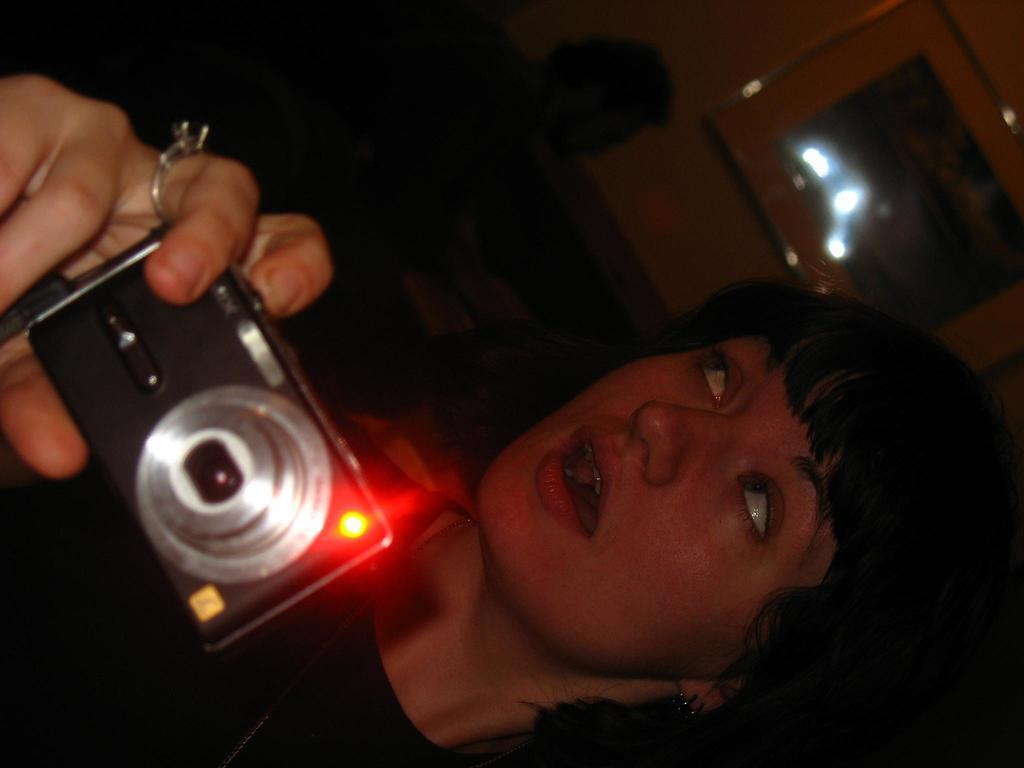Who is the main subject in the image? There is a woman in the image. What is the woman holding in her hand? The woman is holding a camera in her hand. Can you describe the setting of the image? There is another person in the background of the image, and the photo frame is attached to a wall. What type of stamp can be seen on the banana in the image? There is no banana or stamp present in the image. What type of trip is the woman planning in the image? There is no indication of a trip in the image; the woman is simply holding a camera. 